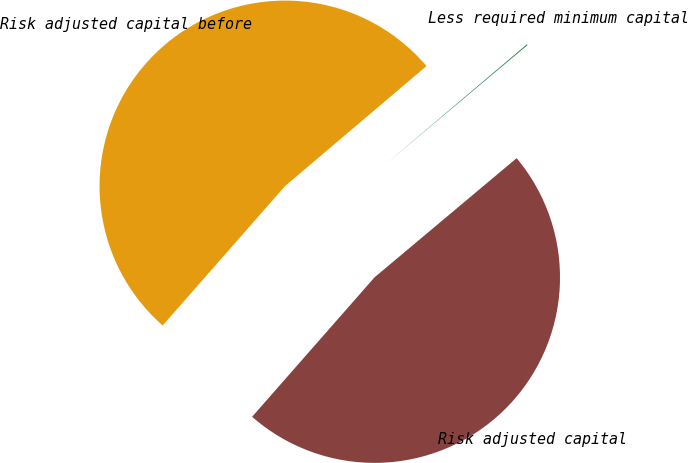<chart> <loc_0><loc_0><loc_500><loc_500><pie_chart><fcel>Risk adjusted capital before<fcel>Less required minimum capital<fcel>Risk adjusted capital<nl><fcel>52.33%<fcel>0.09%<fcel>47.57%<nl></chart> 